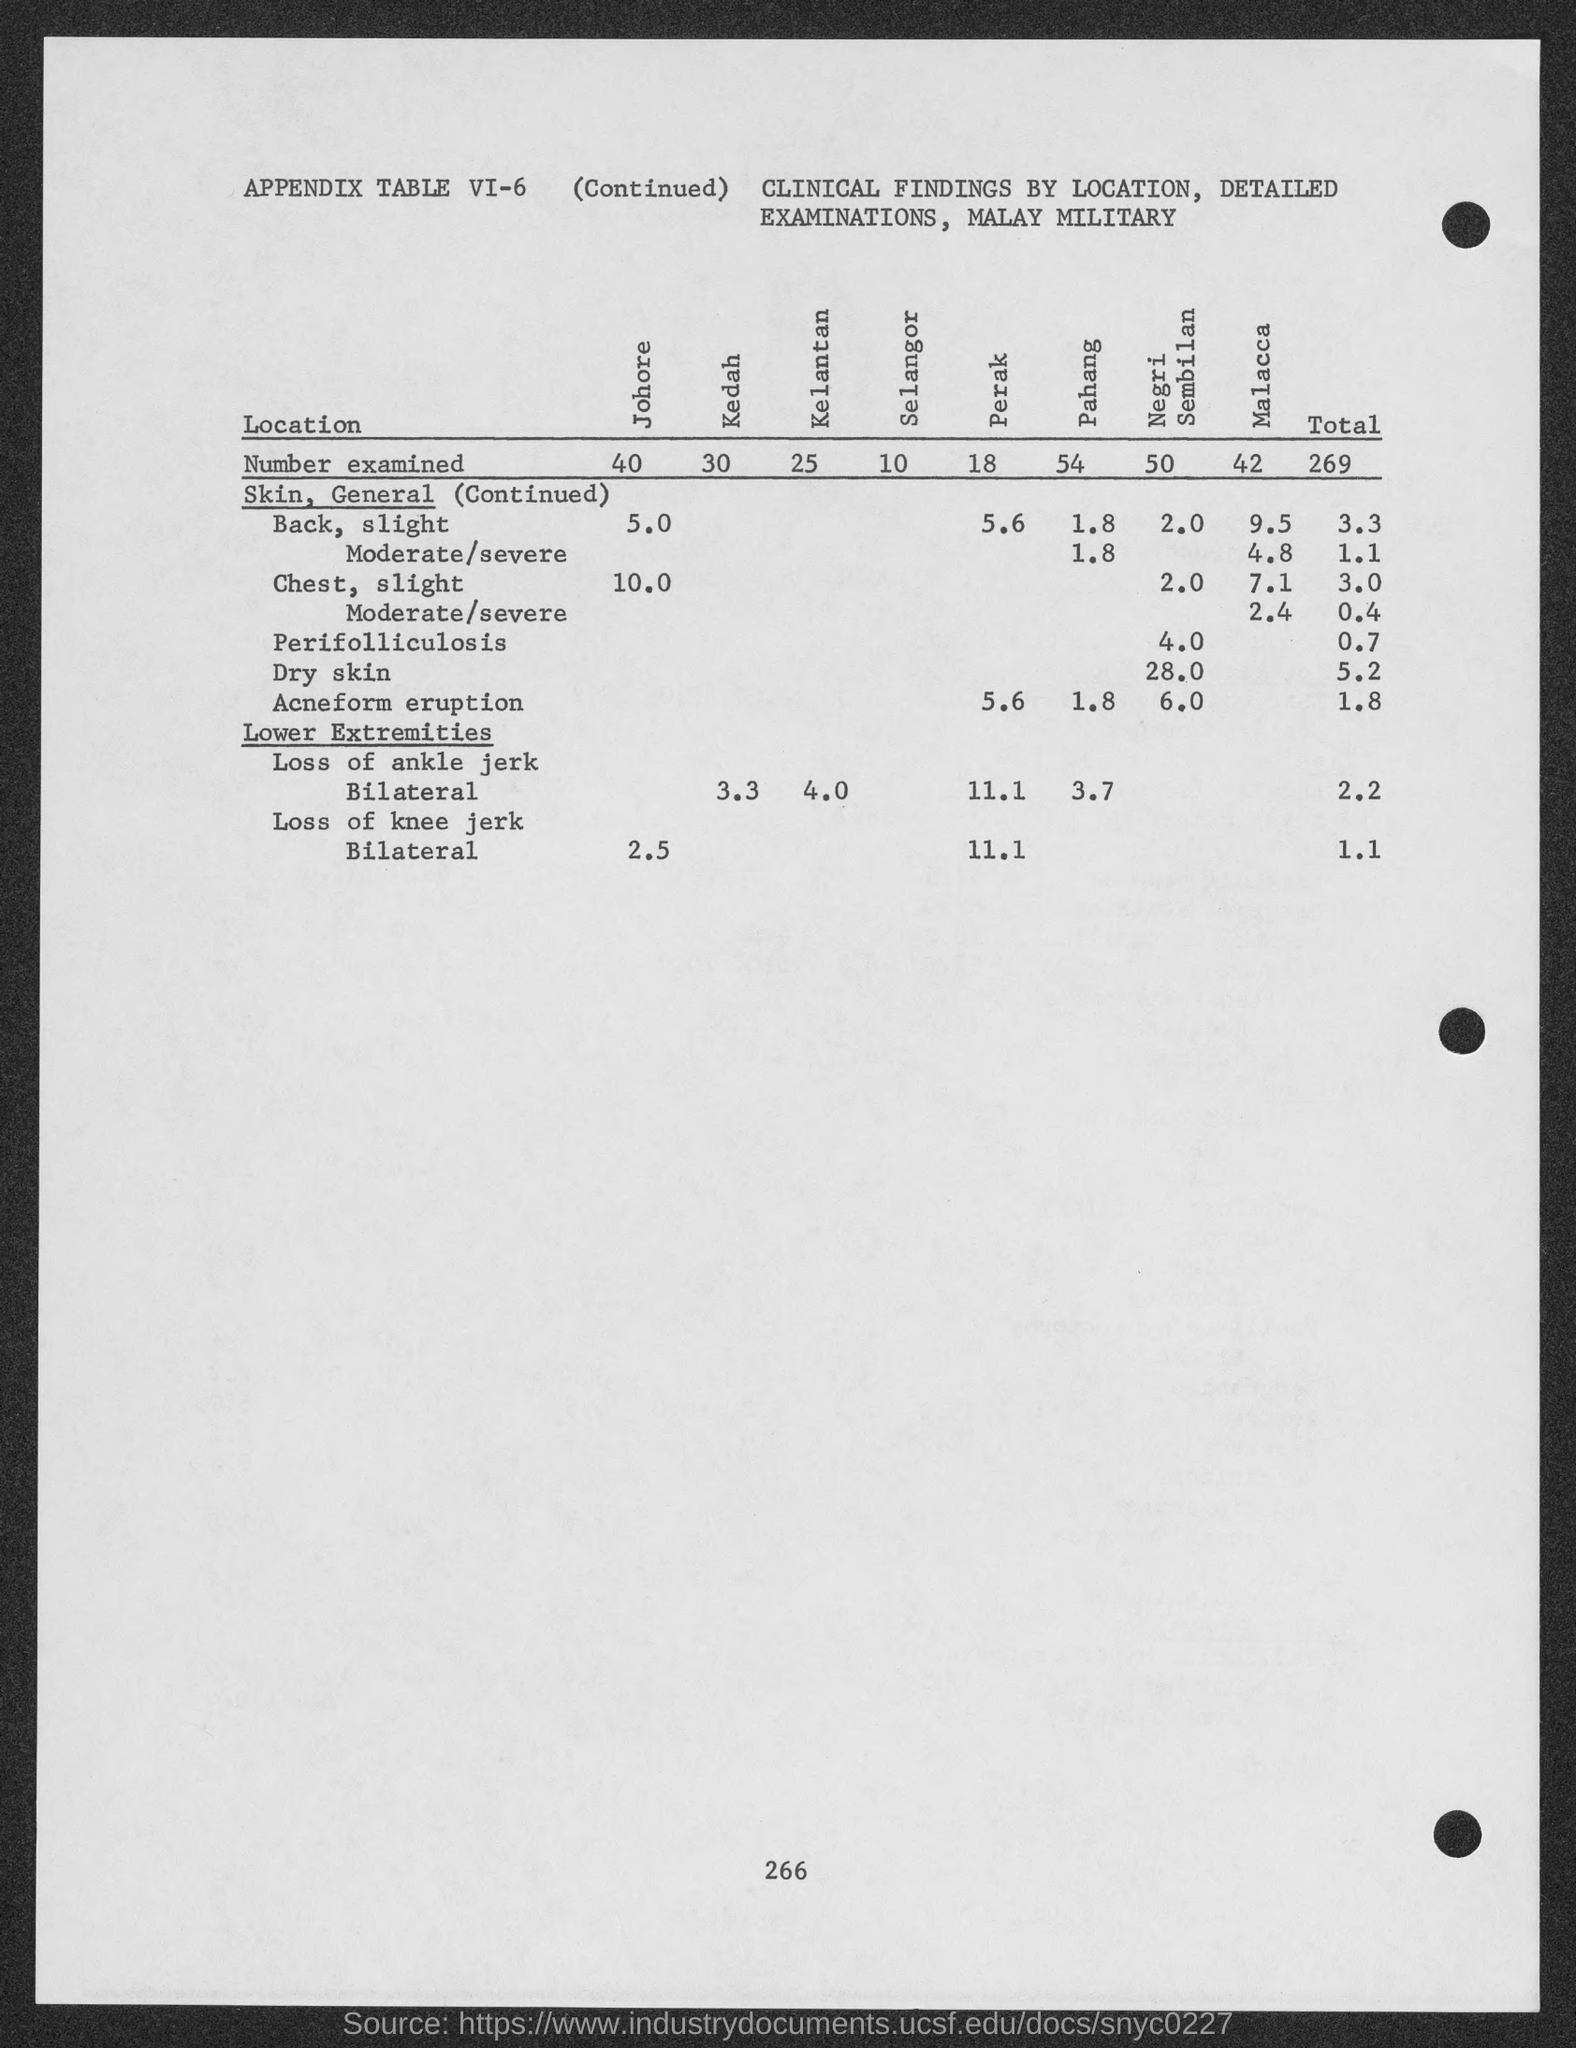Draw attention to some important aspects in this diagram. The number at the bottom of the page is 266. The number examined in Kedah is 30. The number examined in Negri Sembilan is 50. The total number examined is 269. The number being examined in Malacca is 42. 